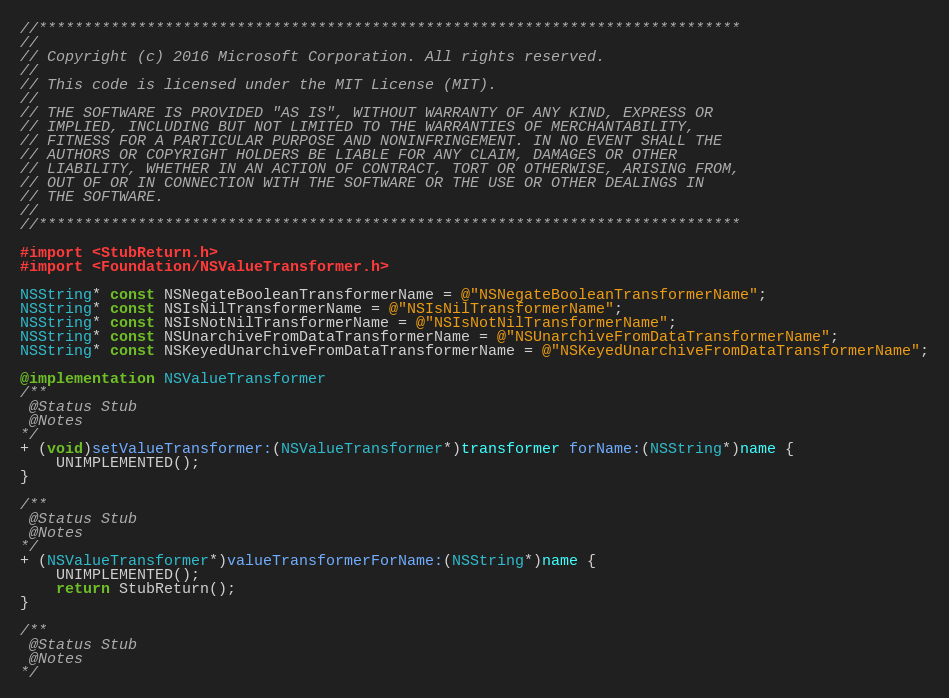<code> <loc_0><loc_0><loc_500><loc_500><_ObjectiveC_>//******************************************************************************
//
// Copyright (c) 2016 Microsoft Corporation. All rights reserved.
//
// This code is licensed under the MIT License (MIT).
//
// THE SOFTWARE IS PROVIDED "AS IS", WITHOUT WARRANTY OF ANY KIND, EXPRESS OR
// IMPLIED, INCLUDING BUT NOT LIMITED TO THE WARRANTIES OF MERCHANTABILITY,
// FITNESS FOR A PARTICULAR PURPOSE AND NONINFRINGEMENT. IN NO EVENT SHALL THE
// AUTHORS OR COPYRIGHT HOLDERS BE LIABLE FOR ANY CLAIM, DAMAGES OR OTHER
// LIABILITY, WHETHER IN AN ACTION OF CONTRACT, TORT OR OTHERWISE, ARISING FROM,
// OUT OF OR IN CONNECTION WITH THE SOFTWARE OR THE USE OR OTHER DEALINGS IN
// THE SOFTWARE.
//
//******************************************************************************

#import <StubReturn.h>
#import <Foundation/NSValueTransformer.h>

NSString* const NSNegateBooleanTransformerName = @"NSNegateBooleanTransformerName";
NSString* const NSIsNilTransformerName = @"NSIsNilTransformerName";
NSString* const NSIsNotNilTransformerName = @"NSIsNotNilTransformerName";
NSString* const NSUnarchiveFromDataTransformerName = @"NSUnarchiveFromDataTransformerName";
NSString* const NSKeyedUnarchiveFromDataTransformerName = @"NSKeyedUnarchiveFromDataTransformerName";

@implementation NSValueTransformer
/**
 @Status Stub
 @Notes
*/
+ (void)setValueTransformer:(NSValueTransformer*)transformer forName:(NSString*)name {
    UNIMPLEMENTED();
}

/**
 @Status Stub
 @Notes
*/
+ (NSValueTransformer*)valueTransformerForName:(NSString*)name {
    UNIMPLEMENTED();
    return StubReturn();
}

/**
 @Status Stub
 @Notes
*/</code> 